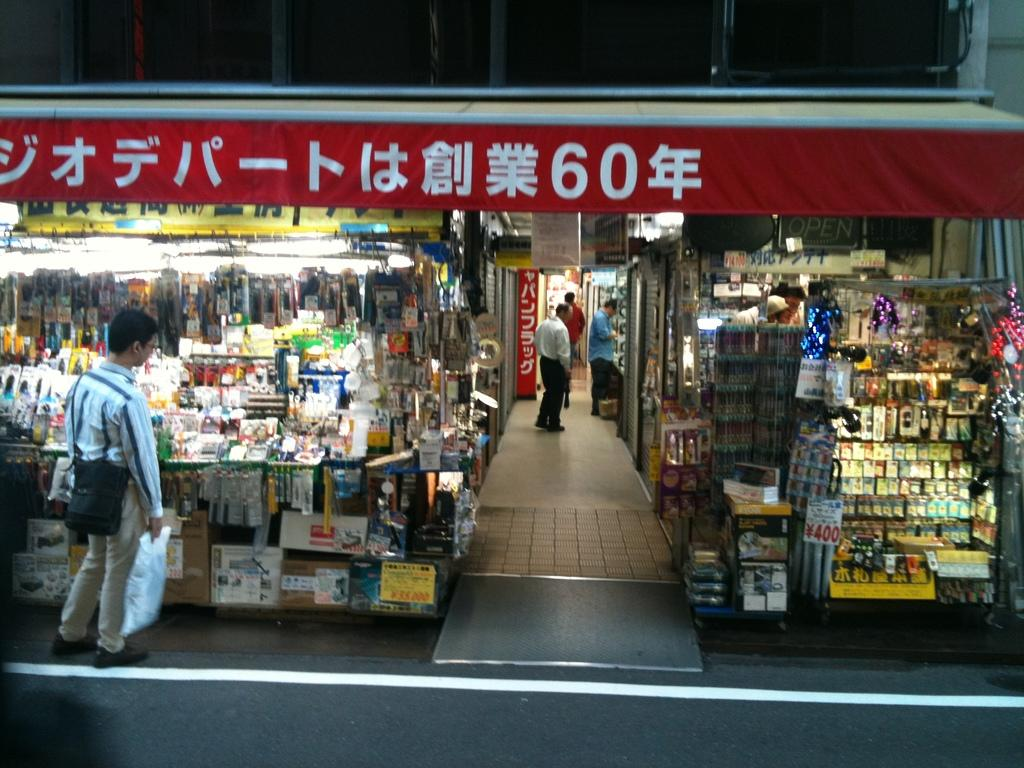<image>
Render a clear and concise summary of the photo. Store front with a red banner that has the number 60 on  it. 